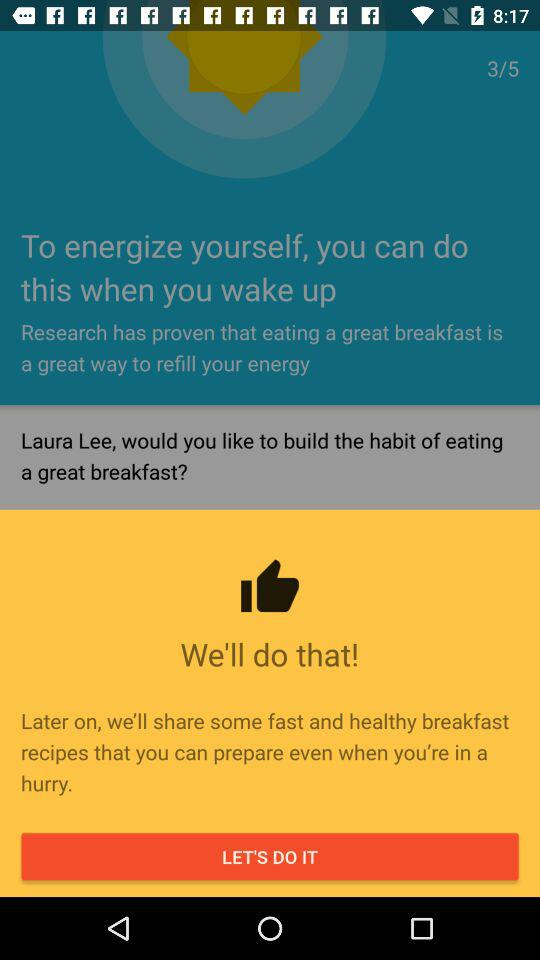How many more steps do I need to complete this habit?
Answer the question using a single word or phrase. 2 